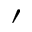Convert formula to latex. <formula><loc_0><loc_0><loc_500><loc_500>^ { \prime }</formula> 